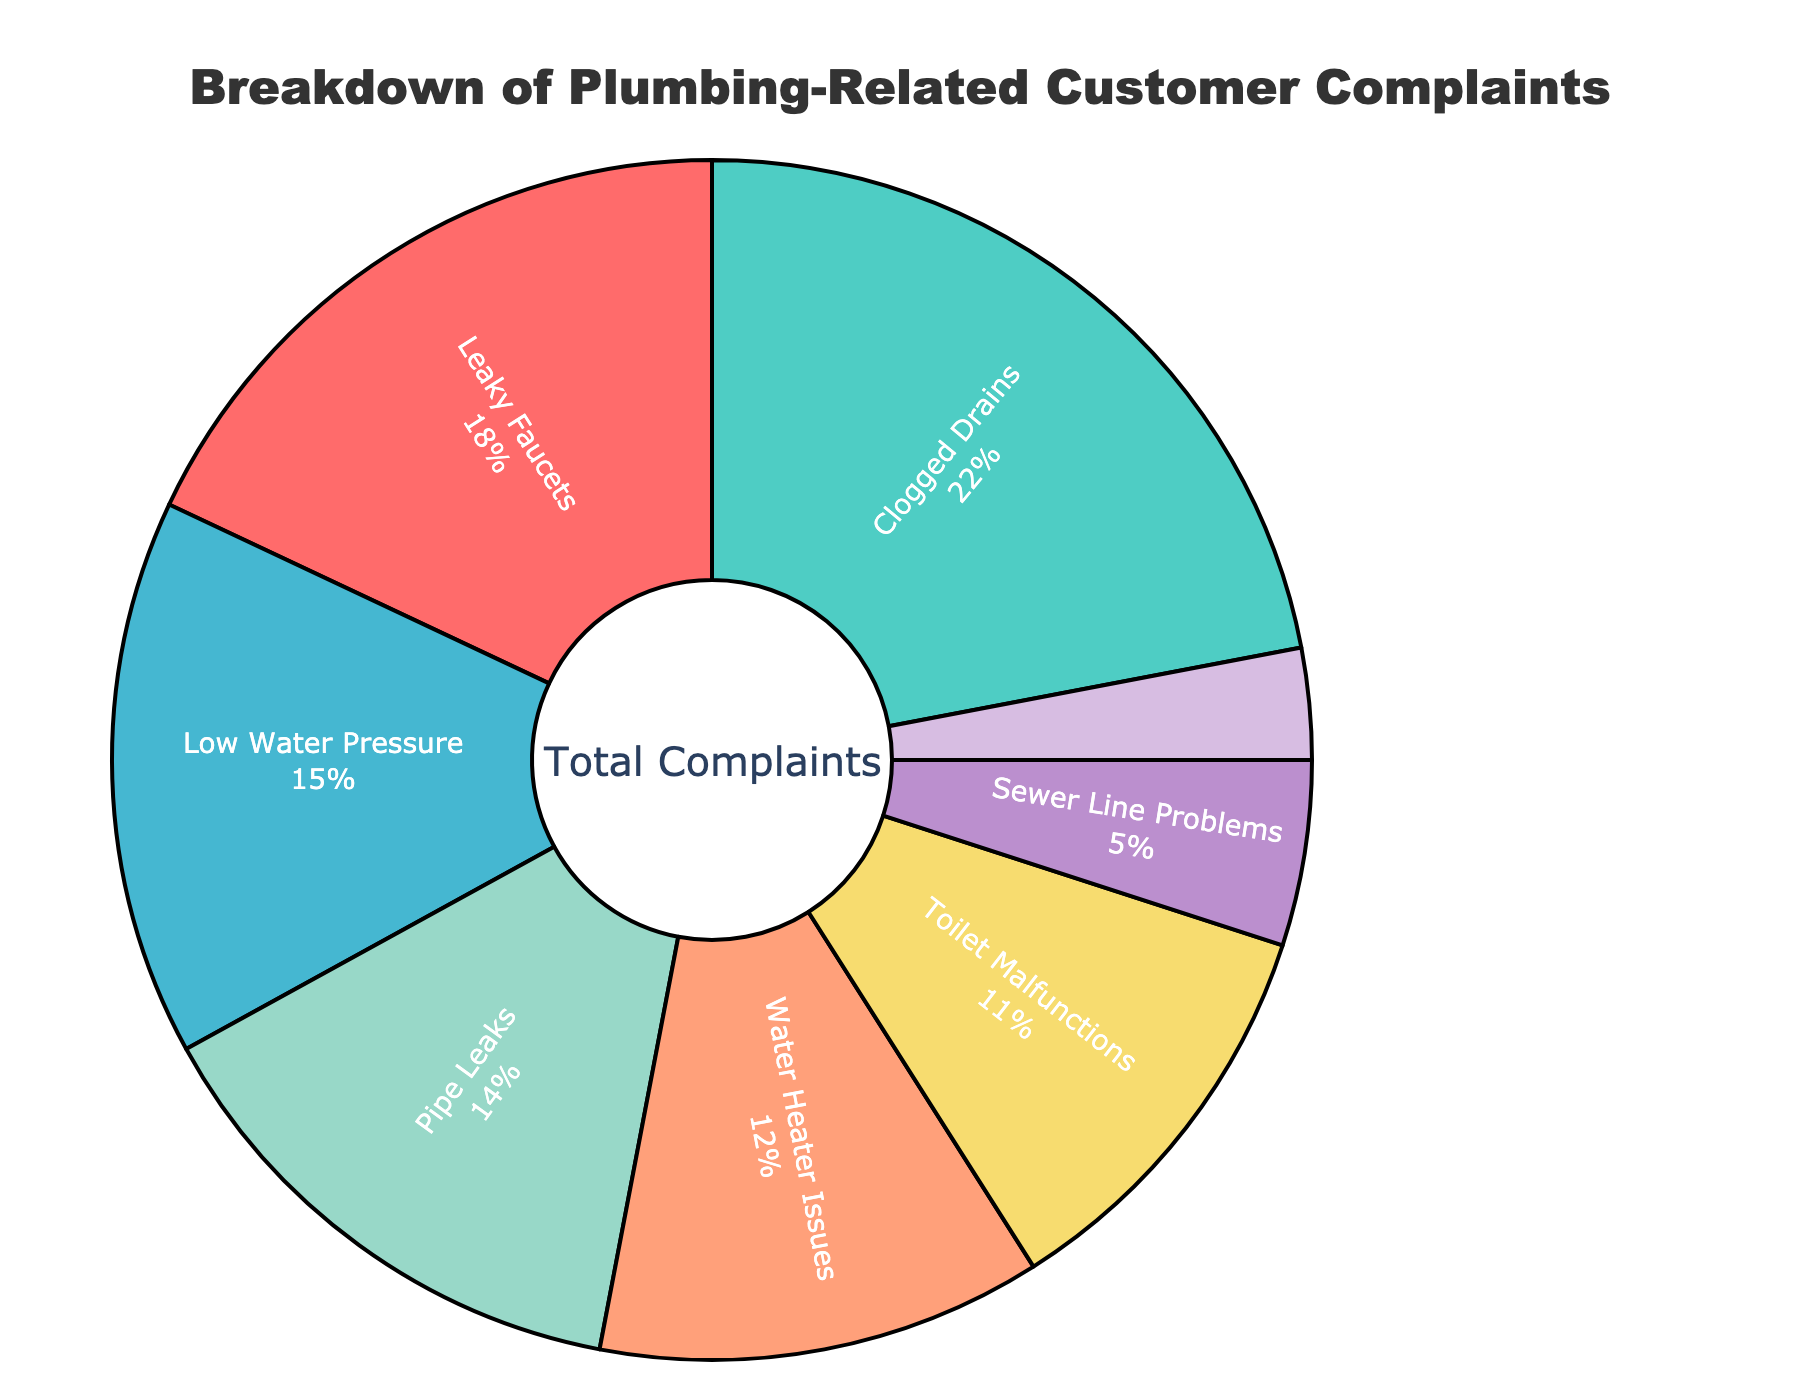What percentage of complaints are due to Leaky Faucets? The pie chart shows the breakdown of plumbing-related customer complaints with corresponding percentages. By referring to the segment labeled "Leaky Faucets," we see that it accounts for 18% of the complaints.
Answer: 18% Which category has the highest percentage of complaints? To determine the category with the highest percentage of complaints, look for the largest segment in the pie chart. "Clogged Drains" is the largest segment, indicating it has the highest percentage.
Answer: Clogged Drains How much more frequent are complaints about Low Water Pressure compared to Fixture Installation Errors? Identify the segments for "Low Water Pressure" and "Fixture Installation Errors" in the pie chart. The percentages for these categories are 15% and 3%, respectively. Subtracting the smaller percentage from the larger shows that complaints about Low Water Pressure are 12% more frequent.
Answer: 12% What is the combined percentage of complaints for Pipe Leaks and Toilet Malfunctions? Find the segments labeled "Pipe Leaks" and "Toilet Malfunctions." Their percentages are 14% and 11%, respectively. Adding these gives a combined percentage of 25%.
Answer: 25% Are there more complaints about Sewer Line Problems or Water Heater Issues? Compare the segments labeled "Sewer Line Problems" and "Water Heater Issues." The pie chart shows that "Water Heater Issues" has a larger percentage (12%) than "Sewer Line Problems" (5%).
Answer: Water Heater Issues What is the smallest category of complaints in the pie chart? Look for the smallest segment in the pie chart. "Fixture Installation Errors" is the smallest segment, accounting for 3% of the complaints.
Answer: Fixture Installation Errors What percentage of complaints are attributed to Clogged Drains, Leaky Faucets, and Low Water Pressure combined? Add the percentages for "Clogged Drains" (22%), "Leaky Faucets" (18%), and "Low Water Pressure" (15%). The combined percentage is 22% + 18% + 15% = 55%.
Answer: 55% What colors represent the categories "Pipe Leaks" and "Leaky Faucets"? Identify the colors by looking at the segments labeled "Pipe Leaks" and "Leaky Faucets" in the pie chart. "Pipe Leaks" is represented by a purple-like color, and "Leaky Faucets" by a red color.
Answer: Purple-like for Pipe Leaks, Red for Leaky Faucets How does the percentage of complaints about Toilet Malfunctions compare to those about Pipe Leaks? Compare the segments "Toilet Malfunctions" (11%) and "Pipe Leaks" (14%). "Pipe Leaks" has a higher percentage of complaints than "Toilet Malfunctions."
Answer: Pipe Leaks has a higher percentage 